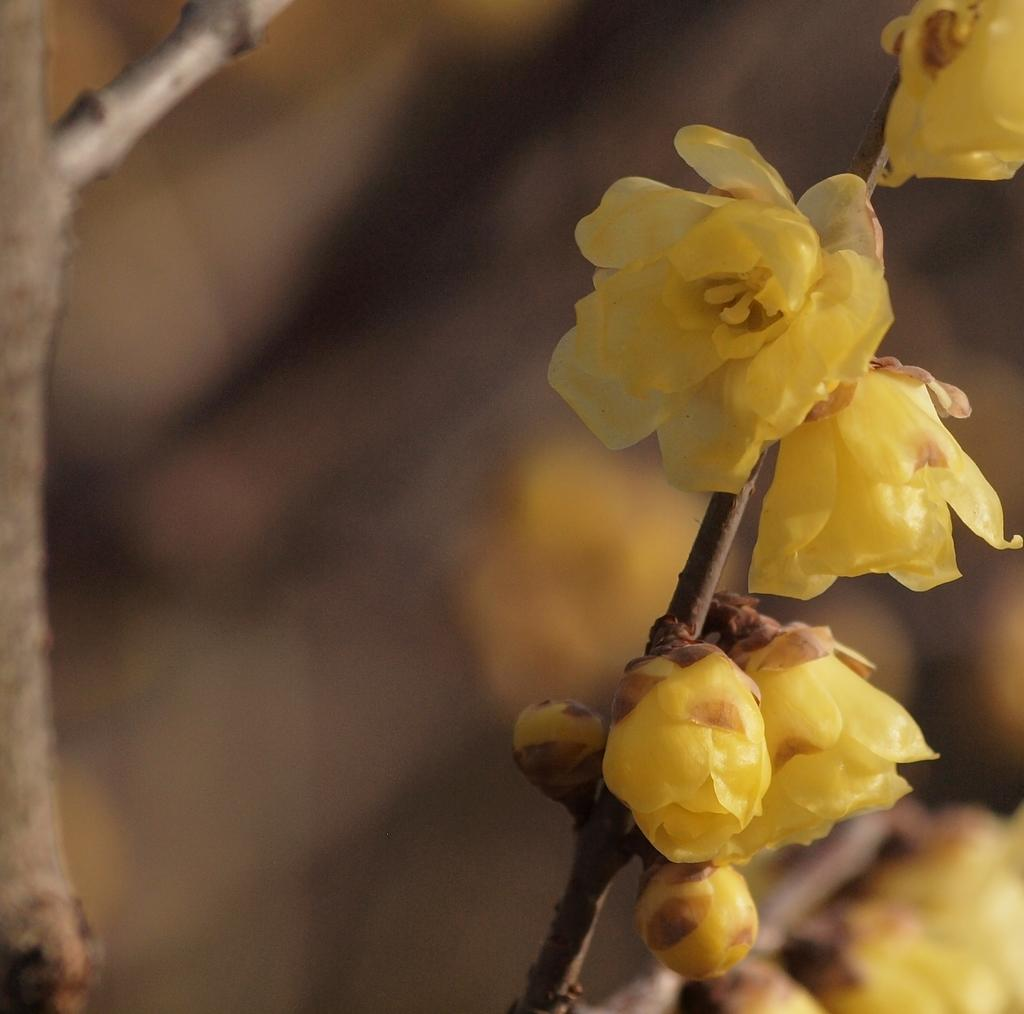What type of flowers can be seen in the image? There are yellow flowers in the image. Where are the flowers located in the image? The flowers are in the front of the image. What can be seen in the background of the image? There is a stick visible in the background of the image. How would you describe the background of the image? The background of the image appears blurry. What type of produce is being harvested by the goat in the image? There is no goat or produce present in the image; it features yellow flowers in the front and a blurry background. How does the image show respect for the flowers? The image does not show respect for the flowers; it is simply a photograph of yellow flowers in the front and a blurry background. 